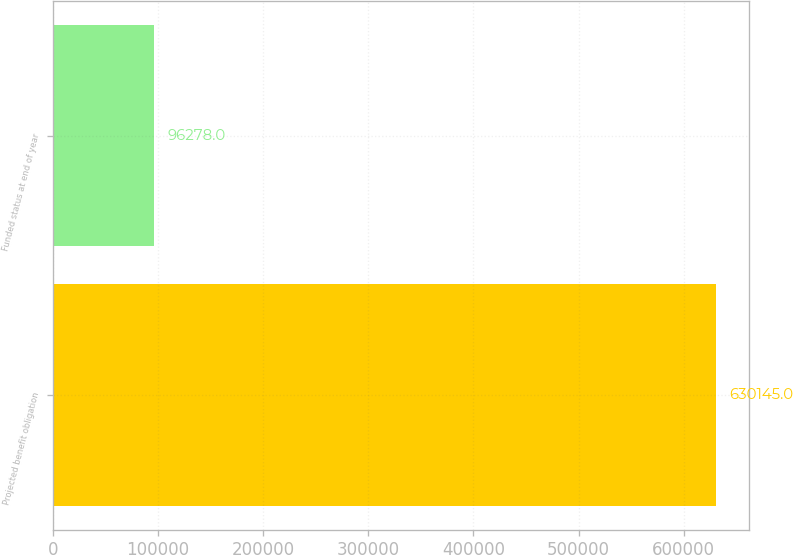Convert chart to OTSL. <chart><loc_0><loc_0><loc_500><loc_500><bar_chart><fcel>Projected benefit obligation<fcel>Funded status at end of year<nl><fcel>630145<fcel>96278<nl></chart> 